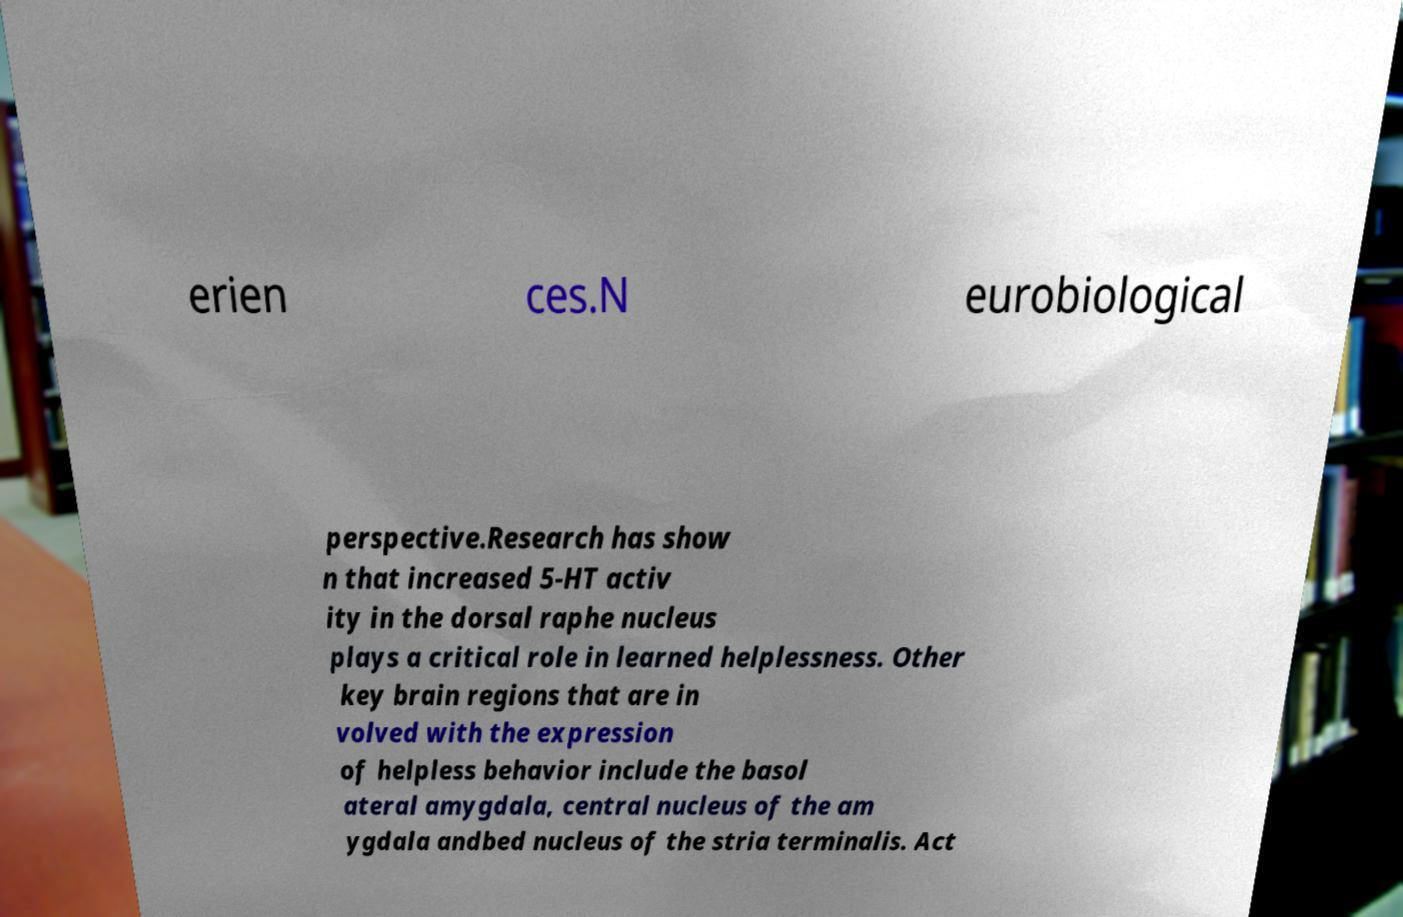Could you extract and type out the text from this image? erien ces.N eurobiological perspective.Research has show n that increased 5-HT activ ity in the dorsal raphe nucleus plays a critical role in learned helplessness. Other key brain regions that are in volved with the expression of helpless behavior include the basol ateral amygdala, central nucleus of the am ygdala andbed nucleus of the stria terminalis. Act 